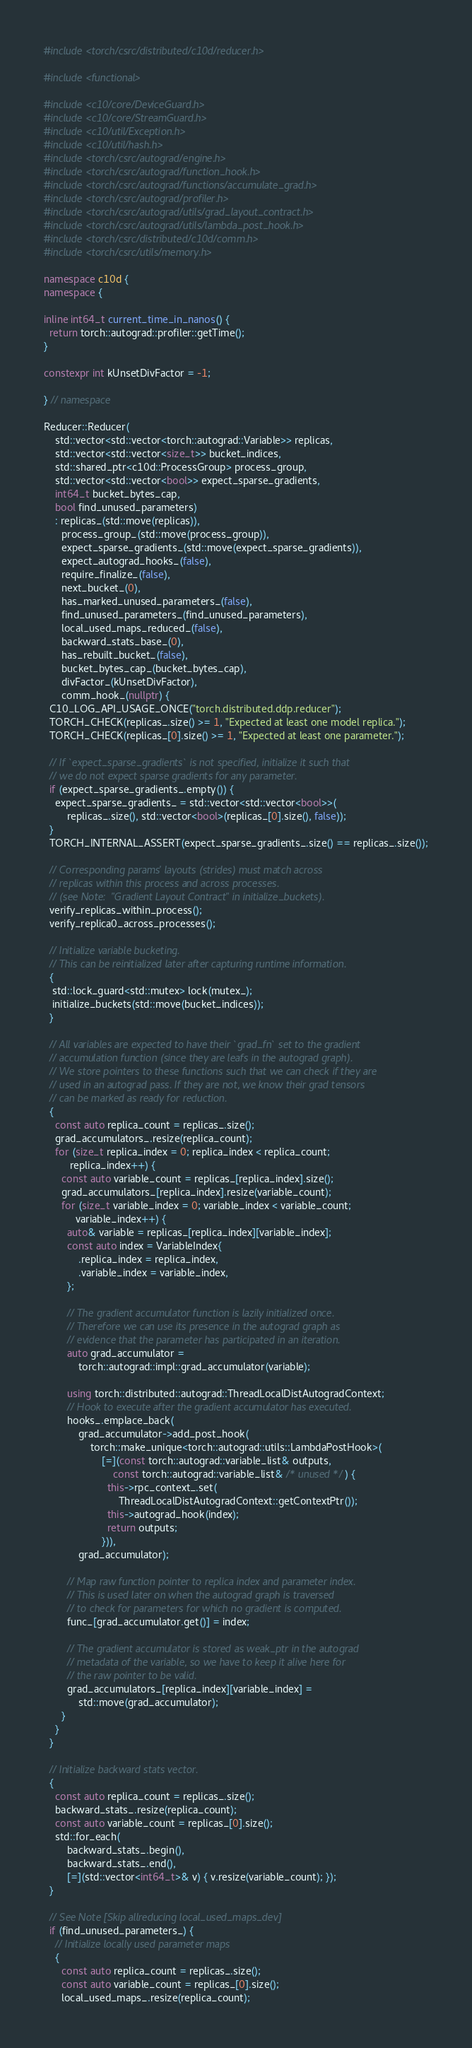Convert code to text. <code><loc_0><loc_0><loc_500><loc_500><_C++_>#include <torch/csrc/distributed/c10d/reducer.h>

#include <functional>

#include <c10/core/DeviceGuard.h>
#include <c10/core/StreamGuard.h>
#include <c10/util/Exception.h>
#include <c10/util/hash.h>
#include <torch/csrc/autograd/engine.h>
#include <torch/csrc/autograd/function_hook.h>
#include <torch/csrc/autograd/functions/accumulate_grad.h>
#include <torch/csrc/autograd/profiler.h>
#include <torch/csrc/autograd/utils/grad_layout_contract.h>
#include <torch/csrc/autograd/utils/lambda_post_hook.h>
#include <torch/csrc/distributed/c10d/comm.h>
#include <torch/csrc/utils/memory.h>

namespace c10d {
namespace {

inline int64_t current_time_in_nanos() {
  return torch::autograd::profiler::getTime();
}

constexpr int kUnsetDivFactor = -1;

} // namespace

Reducer::Reducer(
    std::vector<std::vector<torch::autograd::Variable>> replicas,
    std::vector<std::vector<size_t>> bucket_indices,
    std::shared_ptr<c10d::ProcessGroup> process_group,
    std::vector<std::vector<bool>> expect_sparse_gradients,
    int64_t bucket_bytes_cap,
    bool find_unused_parameters)
    : replicas_(std::move(replicas)),
      process_group_(std::move(process_group)),
      expect_sparse_gradients_(std::move(expect_sparse_gradients)),
      expect_autograd_hooks_(false),
      require_finalize_(false),
      next_bucket_(0),
      has_marked_unused_parameters_(false),
      find_unused_parameters_(find_unused_parameters),
      local_used_maps_reduced_(false),
      backward_stats_base_(0),
      has_rebuilt_bucket_(false),
      bucket_bytes_cap_(bucket_bytes_cap),
      divFactor_(kUnsetDivFactor),
      comm_hook_(nullptr) {
  C10_LOG_API_USAGE_ONCE("torch.distributed.ddp.reducer");
  TORCH_CHECK(replicas_.size() >= 1, "Expected at least one model replica.");
  TORCH_CHECK(replicas_[0].size() >= 1, "Expected at least one parameter.");

  // If `expect_sparse_gradients` is not specified, initialize it such that
  // we do not expect sparse gradients for any parameter.
  if (expect_sparse_gradients_.empty()) {
    expect_sparse_gradients_ = std::vector<std::vector<bool>>(
        replicas_.size(), std::vector<bool>(replicas_[0].size(), false));
  }
  TORCH_INTERNAL_ASSERT(expect_sparse_gradients_.size() == replicas_.size());

  // Corresponding params' layouts (strides) must match across
  // replicas within this process and across processes.
  // (see Note:  "Gradient Layout Contract" in initialize_buckets).
  verify_replicas_within_process();
  verify_replica0_across_processes();

  // Initialize variable bucketing.
  // This can be reinitialized later after capturing runtime information.
  {
   std::lock_guard<std::mutex> lock(mutex_);
   initialize_buckets(std::move(bucket_indices));
  }

  // All variables are expected to have their `grad_fn` set to the gradient
  // accumulation function (since they are leafs in the autograd graph).
  // We store pointers to these functions such that we can check if they are
  // used in an autograd pass. If they are not, we know their grad tensors
  // can be marked as ready for reduction.
  {
    const auto replica_count = replicas_.size();
    grad_accumulators_.resize(replica_count);
    for (size_t replica_index = 0; replica_index < replica_count;
         replica_index++) {
      const auto variable_count = replicas_[replica_index].size();
      grad_accumulators_[replica_index].resize(variable_count);
      for (size_t variable_index = 0; variable_index < variable_count;
           variable_index++) {
        auto& variable = replicas_[replica_index][variable_index];
        const auto index = VariableIndex{
            .replica_index = replica_index,
            .variable_index = variable_index,
        };

        // The gradient accumulator function is lazily initialized once.
        // Therefore we can use its presence in the autograd graph as
        // evidence that the parameter has participated in an iteration.
        auto grad_accumulator =
            torch::autograd::impl::grad_accumulator(variable);

        using torch::distributed::autograd::ThreadLocalDistAutogradContext;
        // Hook to execute after the gradient accumulator has executed.
        hooks_.emplace_back(
            grad_accumulator->add_post_hook(
                torch::make_unique<torch::autograd::utils::LambdaPostHook>(
                    [=](const torch::autograd::variable_list& outputs,
                        const torch::autograd::variable_list& /* unused */) {
                      this->rpc_context_.set(
                          ThreadLocalDistAutogradContext::getContextPtr());
                      this->autograd_hook(index);
                      return outputs;
                    })),
            grad_accumulator);

        // Map raw function pointer to replica index and parameter index.
        // This is used later on when the autograd graph is traversed
        // to check for parameters for which no gradient is computed.
        func_[grad_accumulator.get()] = index;

        // The gradient accumulator is stored as weak_ptr in the autograd
        // metadata of the variable, so we have to keep it alive here for
        // the raw pointer to be valid.
        grad_accumulators_[replica_index][variable_index] =
            std::move(grad_accumulator);
      }
    }
  }

  // Initialize backward stats vector.
  {
    const auto replica_count = replicas_.size();
    backward_stats_.resize(replica_count);
    const auto variable_count = replicas_[0].size();
    std::for_each(
        backward_stats_.begin(),
        backward_stats_.end(),
        [=](std::vector<int64_t>& v) { v.resize(variable_count); });
  }

  // See Note [Skip allreducing local_used_maps_dev]
  if (find_unused_parameters_) {
    // Initialize locally used parameter maps
    {
      const auto replica_count = replicas_.size();
      const auto variable_count = replicas_[0].size();
      local_used_maps_.resize(replica_count);</code> 